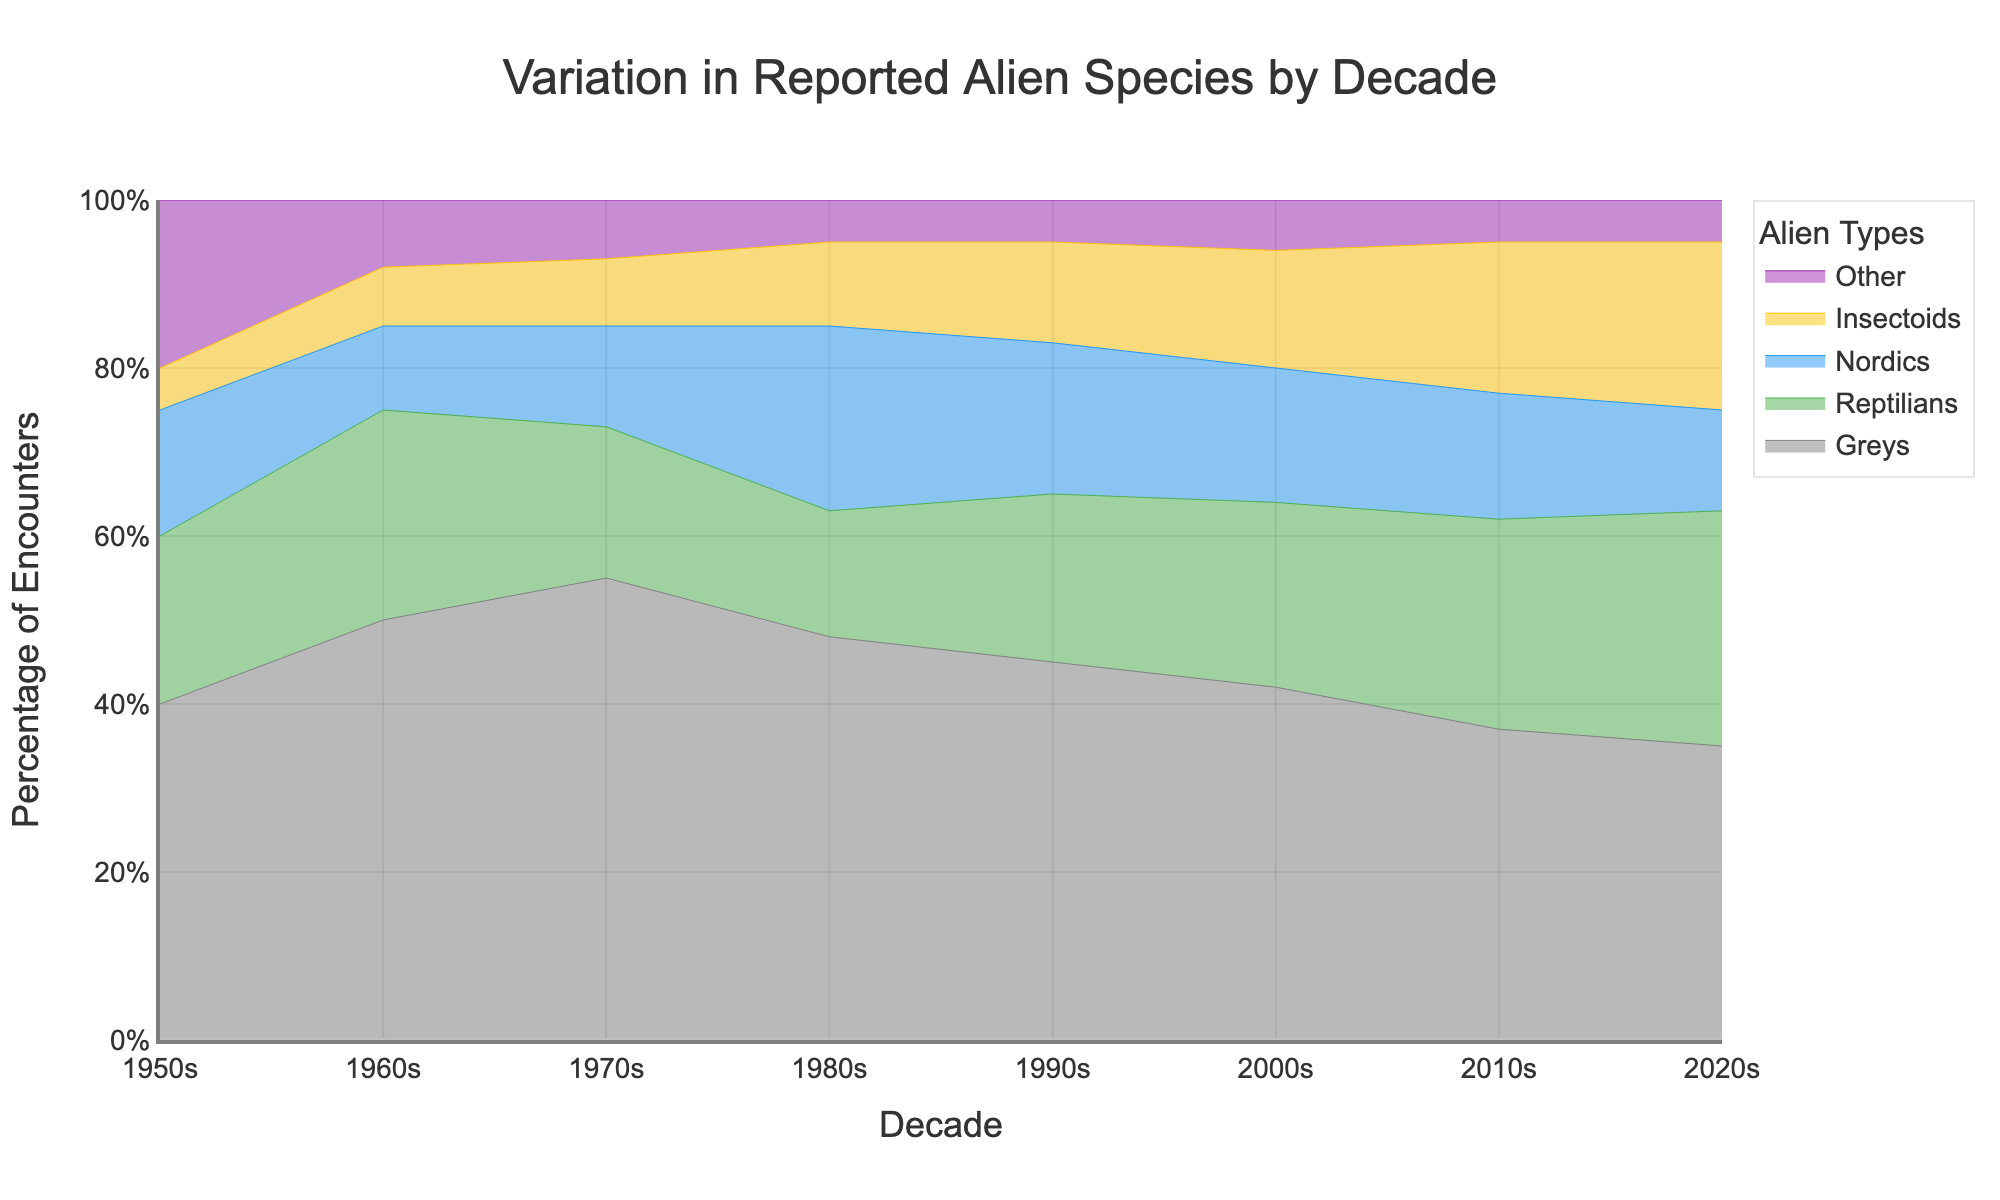What's the title of the chart? The title of the chart is explicitly mentioned at the top of the chart, which helps viewers quickly understand the context and subject of the data being presented.
Answer: Variation in Reported Alien Species by Decade What is the percentage of encounters featuring Nordics in the 1980s? Locate the 1980s on the x-axis, then look at the color band representing Nordics, which corresponds to a certain percentage on the y-axis. The chart illustrates that 22% of encounters featured Nordics in the 1980s.
Answer: 22% Between which decades did the percentage of encounters with Insectoids increase the most? Observe the yellow band representing Insectoids. Compare its height increase between each decade. The most significant rise is between the 2010s and 2020s, where it grows from 18% to 20%.
Answer: 2010s to 2020s How has the percentage of encounters with Greys changed from the 1950s to the 2020s? Track the grey band representing encounters with Greys starting from the 1950s to the 2020s. Note the percentage values: 40% in the 1950s decreasing steadily to 35% in the 2020s.
Answer: It decreased by 5% Which alien type had the most consistent percentage of encounters across decades? Assess each color band's height changes over the decades. The "Other" category maintains a relatively stable percentage between 5% and 8%, indicating its consistency compared to other types.
Answer: Other In which decade did Reptilians first exceed 20% of encounters? Trace the green band representing Reptilians and identify the decade when it first crossed the 20% mark. The chart shows it occurring in the 2000s.
Answer: 2000s Which two alien types had their percentage intersect around the 1970s? Examine where two color bands intersect in the 1970s. The bands representing Reptilians (green) and Nordics (blue) intersect around this decade.
Answer: Reptilians and Nordics What is the difference in percentage of encounters featuring Greys between the 1960s and the 2020s? Refer to the percentages for Greys in both decades: 50% in the 1960s and 35% in the 2020s. Subtract the latter from the former to find the difference: 50% - 35% = 15%.
Answer: 15% Which alien type shows the most noticeable increase in encounters from the 2000s to the 2010s? Compare the changes in height for each color band between the two decades. The yellow band for Insectoids shows the biggest rise, increasing from 14% to 18%.
Answer: Insectoids 